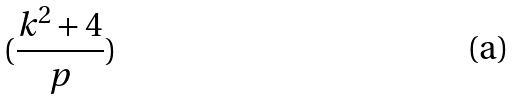<formula> <loc_0><loc_0><loc_500><loc_500>( \frac { k ^ { 2 } + 4 } { p } )</formula> 